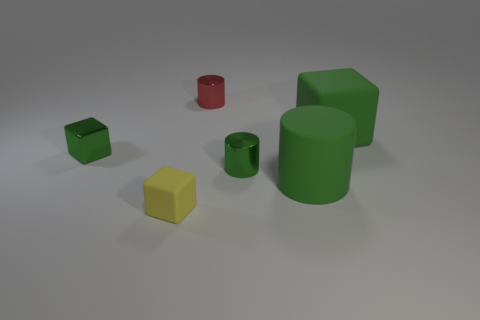There is a large thing behind the large green cylinder; is there a large green thing that is behind it?
Offer a very short reply. No. Are there any green cylinders to the left of the small metallic object in front of the tiny metal block behind the yellow thing?
Provide a short and direct response. No. Does the big green thing that is behind the rubber cylinder have the same shape as the metallic object left of the yellow object?
Provide a short and direct response. Yes. The other small cylinder that is the same material as the red cylinder is what color?
Offer a terse response. Green. Is the number of red cylinders that are left of the green metallic cube less than the number of things?
Your answer should be compact. Yes. There is a green object that is to the left of the metal object that is behind the big rubber object that is behind the tiny green cylinder; what size is it?
Give a very brief answer. Small. Is the material of the big green object in front of the green rubber cube the same as the small yellow object?
Offer a very short reply. Yes. What material is the large thing that is the same color as the big rubber cylinder?
Offer a very short reply. Rubber. Is there any other thing that is the same shape as the red object?
Provide a short and direct response. Yes. What number of things are either rubber blocks or green rubber things?
Give a very brief answer. 3. 